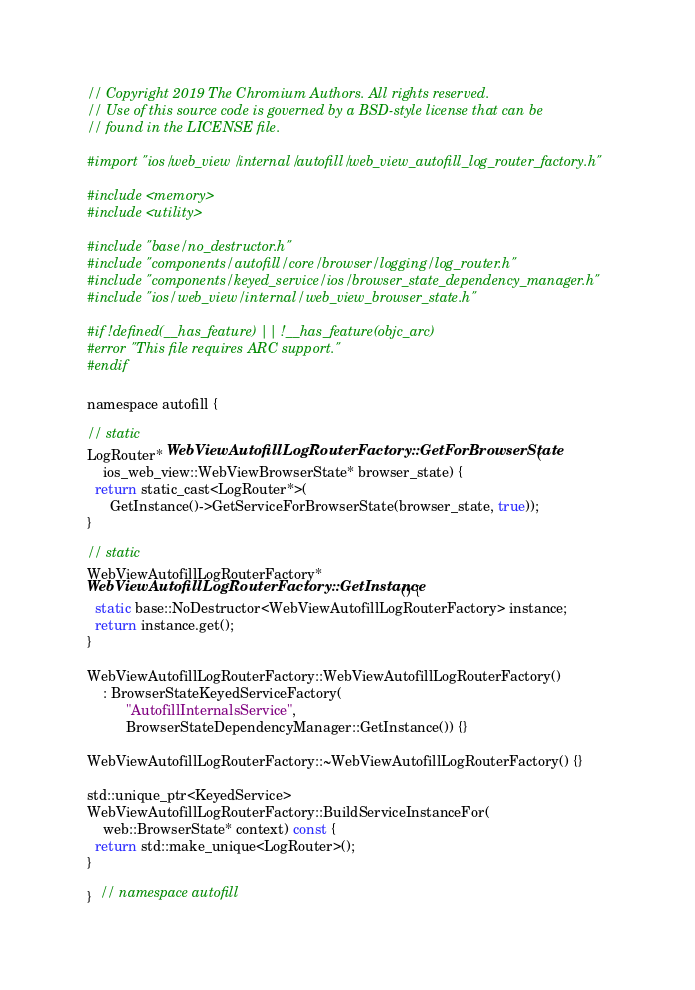Convert code to text. <code><loc_0><loc_0><loc_500><loc_500><_ObjectiveC_>// Copyright 2019 The Chromium Authors. All rights reserved.
// Use of this source code is governed by a BSD-style license that can be
// found in the LICENSE file.

#import "ios/web_view/internal/autofill/web_view_autofill_log_router_factory.h"

#include <memory>
#include <utility>

#include "base/no_destructor.h"
#include "components/autofill/core/browser/logging/log_router.h"
#include "components/keyed_service/ios/browser_state_dependency_manager.h"
#include "ios/web_view/internal/web_view_browser_state.h"

#if !defined(__has_feature) || !__has_feature(objc_arc)
#error "This file requires ARC support."
#endif

namespace autofill {

// static
LogRouter* WebViewAutofillLogRouterFactory::GetForBrowserState(
    ios_web_view::WebViewBrowserState* browser_state) {
  return static_cast<LogRouter*>(
      GetInstance()->GetServiceForBrowserState(browser_state, true));
}

// static
WebViewAutofillLogRouterFactory*
WebViewAutofillLogRouterFactory::GetInstance() {
  static base::NoDestructor<WebViewAutofillLogRouterFactory> instance;
  return instance.get();
}

WebViewAutofillLogRouterFactory::WebViewAutofillLogRouterFactory()
    : BrowserStateKeyedServiceFactory(
          "AutofillInternalsService",
          BrowserStateDependencyManager::GetInstance()) {}

WebViewAutofillLogRouterFactory::~WebViewAutofillLogRouterFactory() {}

std::unique_ptr<KeyedService>
WebViewAutofillLogRouterFactory::BuildServiceInstanceFor(
    web::BrowserState* context) const {
  return std::make_unique<LogRouter>();
}

}  // namespace autofill
</code> 